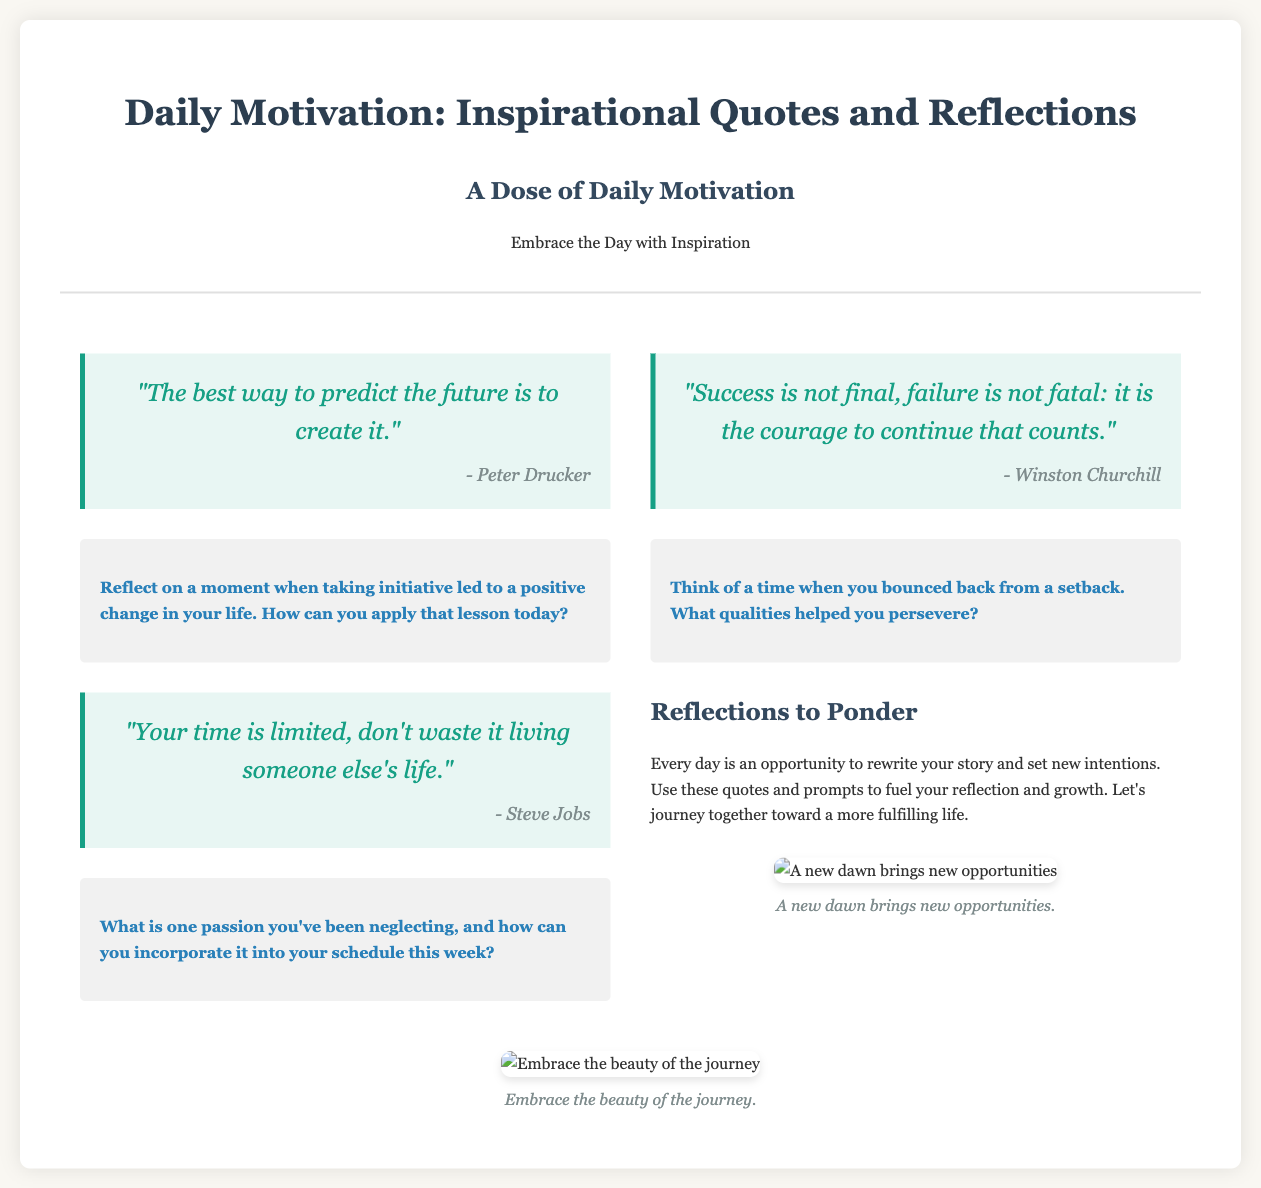What is the title of the section? The title of the section is prominently displayed at the top of the document.
Answer: Daily Motivation: Inspirational Quotes and Reflections Who is quoted for "The best way to predict the future is to create it"? The author of the quote can be found below the quote itself.
Answer: Peter Drucker What is the reflection prompt for Steve Jobs' quote? The reflection prompt is provided in a dedicated section below each quote.
Answer: What is one passion you've been neglecting, and how can you incorporate it into your schedule this week? How many quotes are included in the left column? The left column contains quotes on separate lines within the designated sections.
Answer: 2 What is the main theme of the section? The theme is reinforced by the header and the descriptions provided.
Answer: Daily motivation and inspiration What color is used for the reflective journal prompts? The color specified for the journal prompts can be identified in the document styling.
Answer: #2980b9 What type of images are included in the document? The type of images is described in the context where they are placed in the layout.
Answer: Inspirational images What notable figure's quote is attributed to the concept of perseverance? The document attributes a quote about perseverance to a well-known historical figure.
Answer: Winston Churchill 